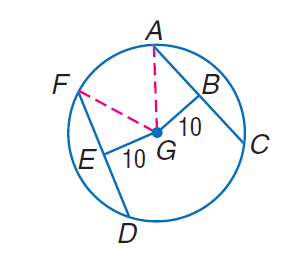Answer the mathemtical geometry problem and directly provide the correct option letter.
Question: Chords A C and D F are equidistant from the center. If the radius of \odot G is 26, find D E.
Choices: A: 12 B: 20 C: 24 D: 26 C 